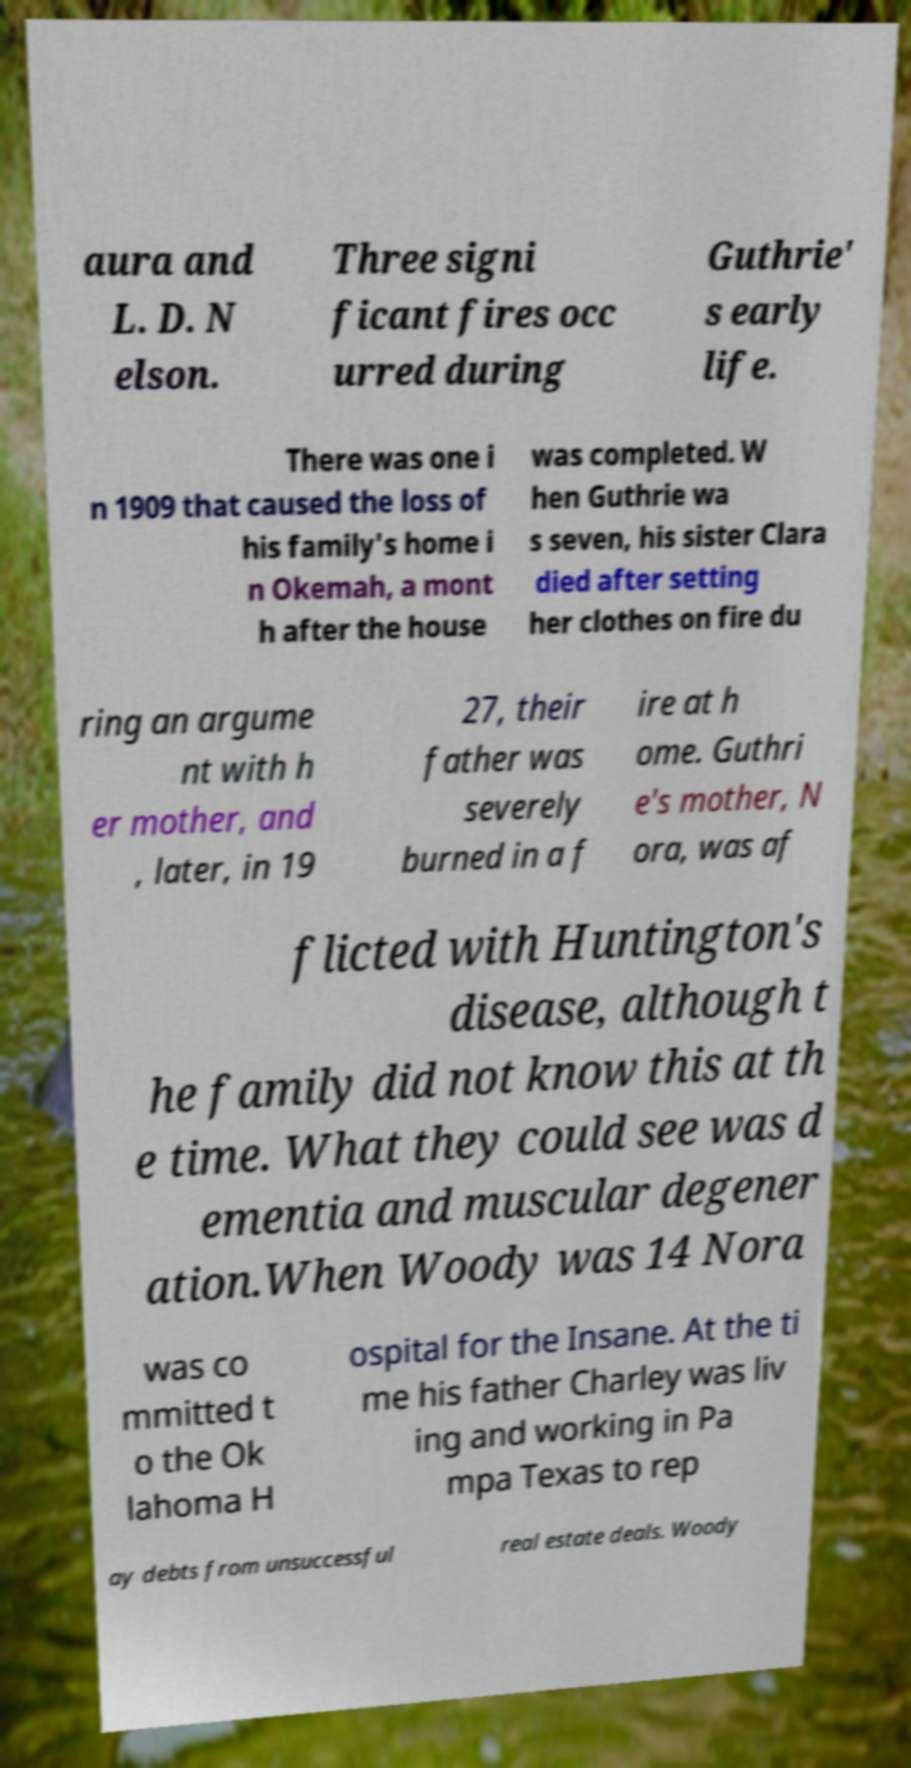Please identify and transcribe the text found in this image. aura and L. D. N elson. Three signi ficant fires occ urred during Guthrie' s early life. There was one i n 1909 that caused the loss of his family's home i n Okemah, a mont h after the house was completed. W hen Guthrie wa s seven, his sister Clara died after setting her clothes on fire du ring an argume nt with h er mother, and , later, in 19 27, their father was severely burned in a f ire at h ome. Guthri e's mother, N ora, was af flicted with Huntington's disease, although t he family did not know this at th e time. What they could see was d ementia and muscular degener ation.When Woody was 14 Nora was co mmitted t o the Ok lahoma H ospital for the Insane. At the ti me his father Charley was liv ing and working in Pa mpa Texas to rep ay debts from unsuccessful real estate deals. Woody 